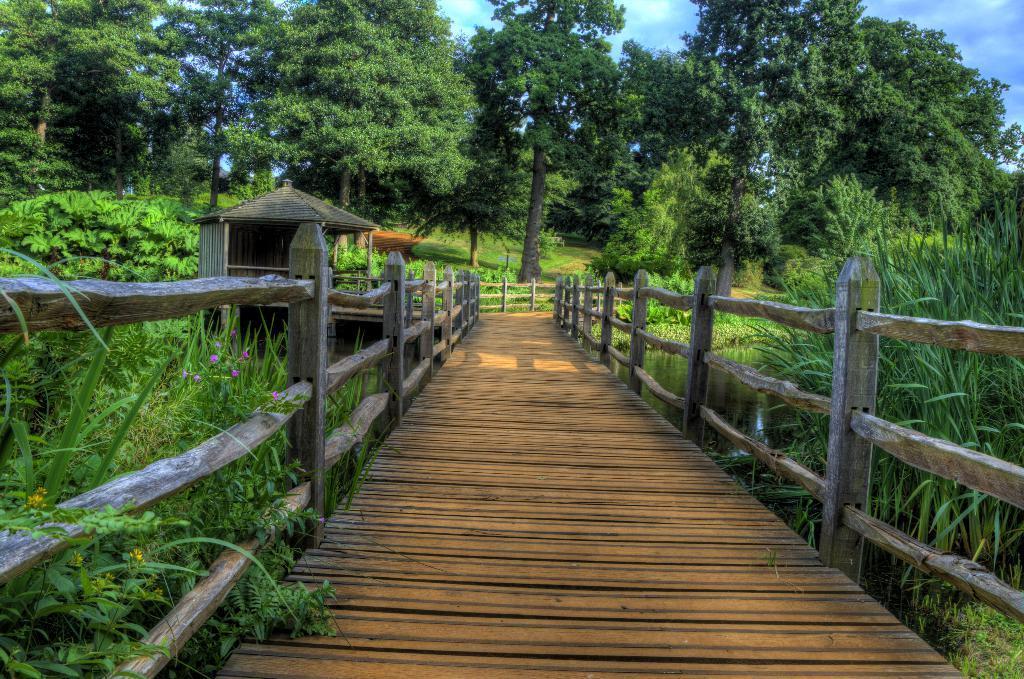How would you summarize this image in a sentence or two? There is a bridge having wooden floor and wooden fencing. It is built across the river. On both sides of this bridge, there are plants. In the background, there are plants, trees and grass on the ground and there are clouds in the blue sky. 